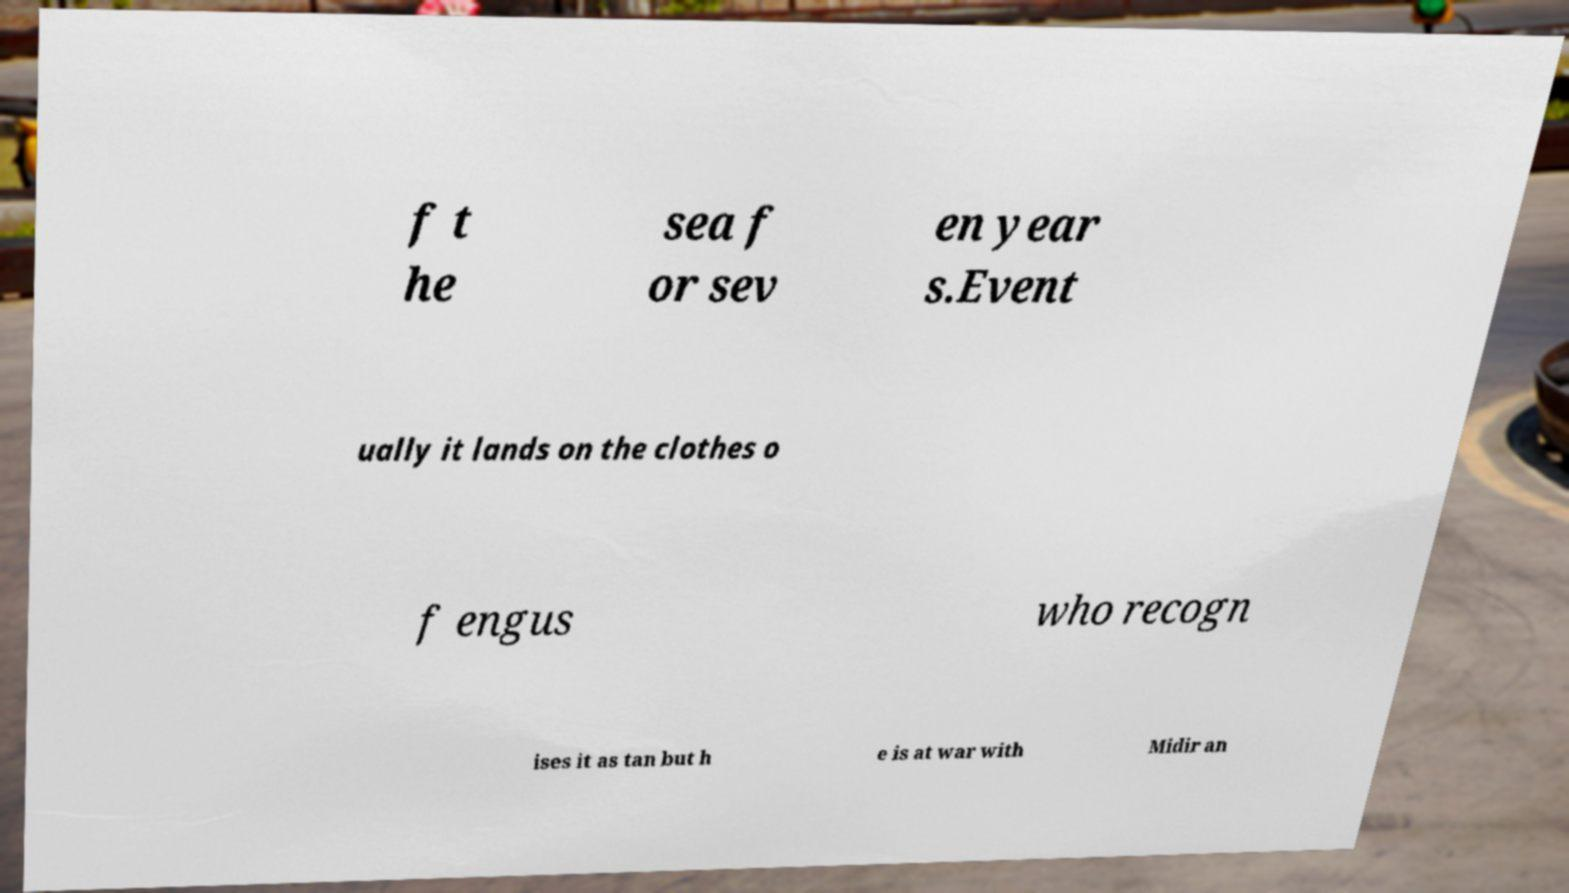Please read and relay the text visible in this image. What does it say? f t he sea f or sev en year s.Event ually it lands on the clothes o f engus who recogn ises it as tan but h e is at war with Midir an 